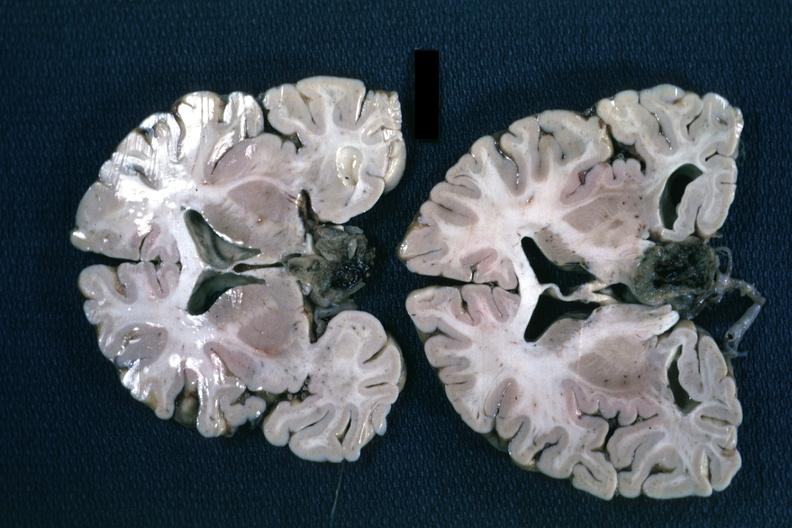s peritoneal fluid present?
Answer the question using a single word or phrase. No 